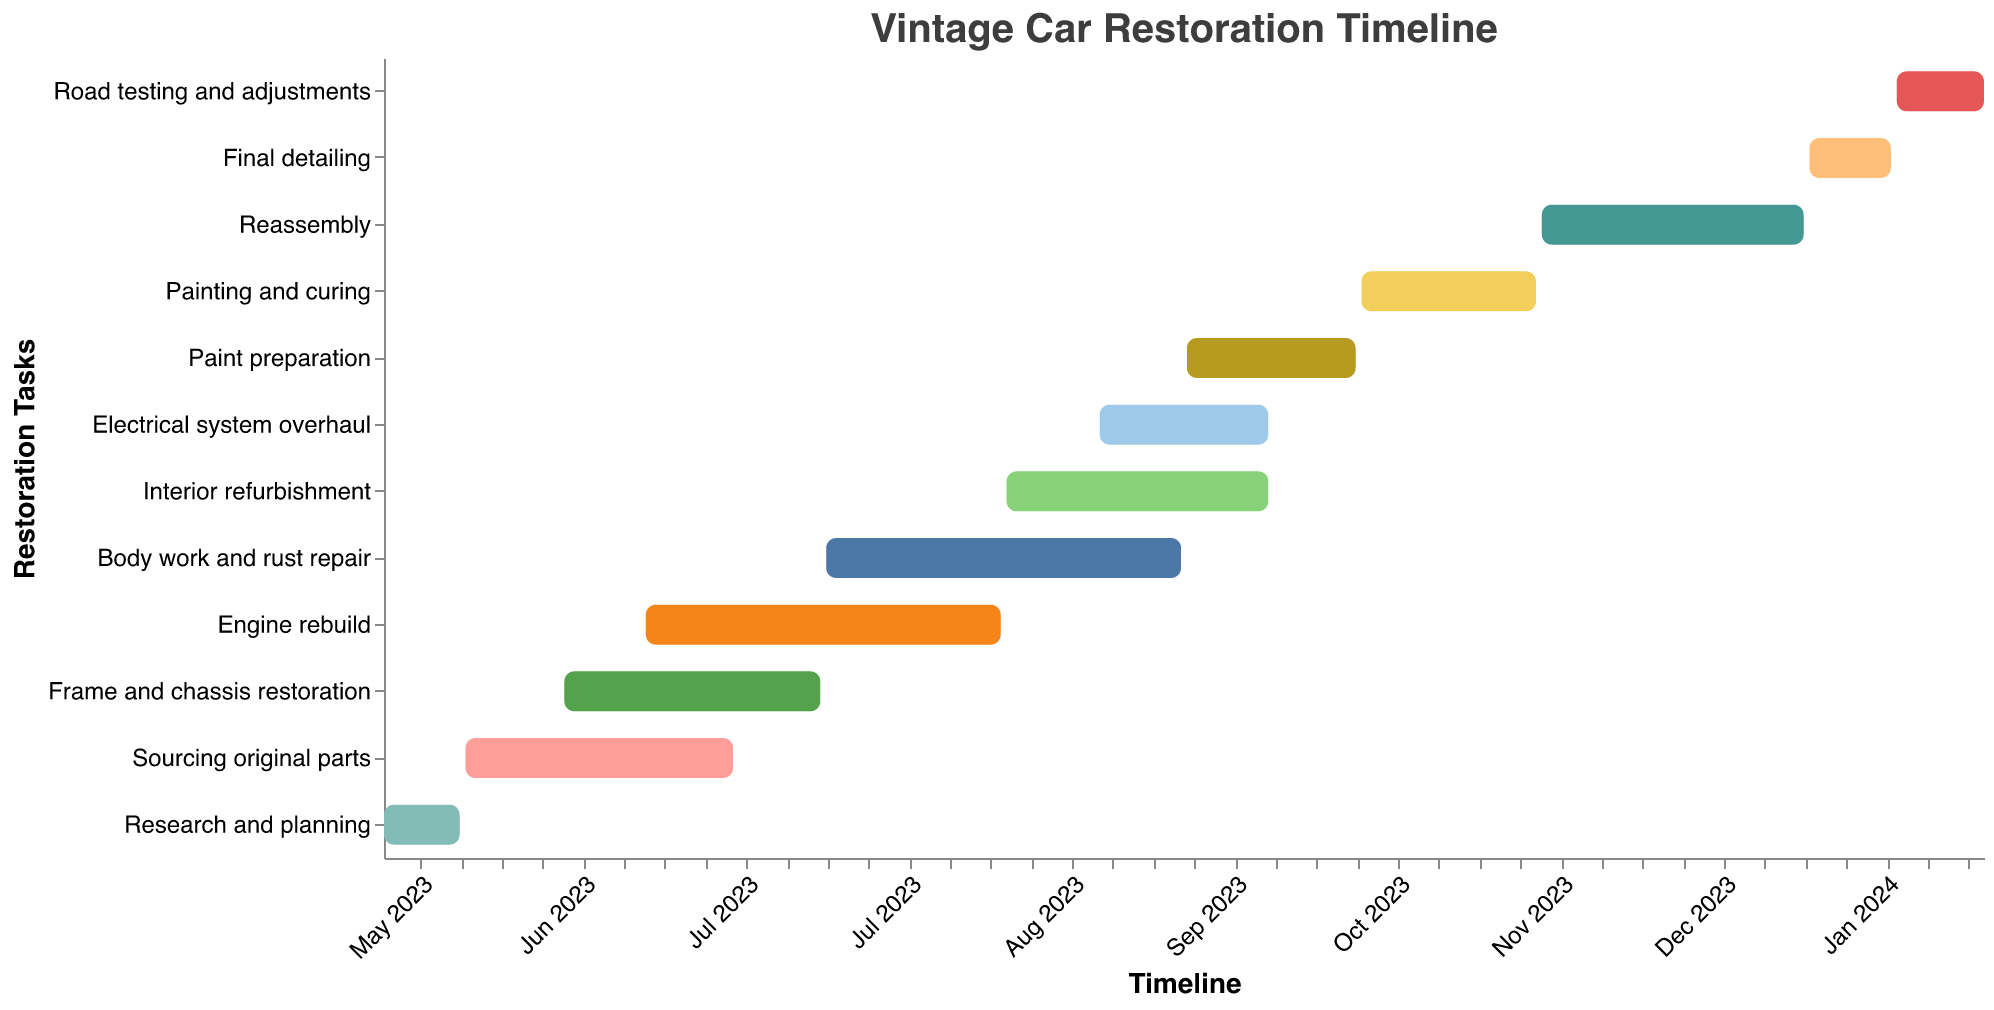What is the title of the Gantt chart? The title is usually displayed at the top of the figure, summarizing what the chart represents. In this case, the title is specified in the data provided.
Answer: Vintage Car Restoration Timeline Which task has the longest duration? To find the task with the longest duration, you observe the "Duration (days)" for each task in the chart. The task with the highest number is the one with the longest duration.
Answer: Engine rebuild When does the "Frame and chassis restoration" task start and end? The starting and ending dates of the "Frame and chassis restoration" task can be seen directly on its corresponding bar in the chart.
Answer: June 1, 2023 - July 15, 2023 Which task overlaps with "Engine rebuild" and by how many days? To determine which task overlaps with "Engine rebuild," you check the start and end dates of each task. Tasks overlapping with "Engine rebuild," which spans from June 15, 2023, to August 15, 2023, must share dates within this range. Then, you count the overlapping days.
Answer: Frame and chassis restoration overlaps by 1 day (June 15, 2023), Body work and rust repair overlaps by 31 days (July 16, 2023 - August 15, 2023) Which tasks are scheduled to run during September 2023? Checking the dates within September 2023 (September 1 - September 30), you identify tasks running within this period by looking at their start and end dates.
Answer: Body work and rust repair, Interior refurbishment, Electrical system overhaul, Paint preparation How many days of restoration tasks are planned for before the end of July 2023? Sum the durations of tasks with end dates before July 31, 2023. Tasks and respective durations included are "Research and planning" (14 days) and "Sourcing original parts" (47 days), and contributions up to July 31 for "Frame and chassis restoration" (45 days by July 15) and part of "Engine rebuild" (46 days up to July 31).
Answer: 152 days Which tasks have a duration of exactly 30 days? You can identify tasks with a duration of 30 days by looking at the "Duration (days)" column values listed.
Answer: Electrical system overhaul, Paint preparation What follows the task "Painting and curing"? The task directly following "Painting and curing" is determined by looking at the sequence of tasks and their start and end dates. The task starting right after "Painting and curing" ends (November 15, 2023) is the next one.
Answer: Reassembly Which task(s) share the starting date with the "Electrical system overhaul" task? For tasks sharing the same start date, you compare each task's "Start Date" with the start date of the "Electrical system overhaul" (September 1, 2023).
Answer: None Which is the last task in the restoration timeline? The last task is identified by looking at the task that extends to the last date on the timeline, which includes the entire period up to the end date of the restoration project.
Answer: Road testing and adjustments 